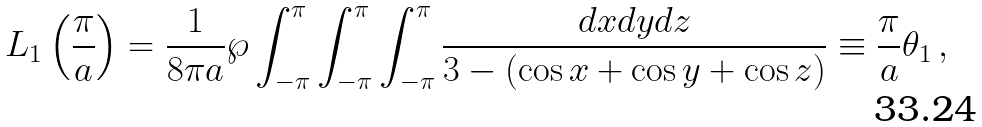<formula> <loc_0><loc_0><loc_500><loc_500>L _ { 1 } \left ( \frac { \pi } { a } \right ) = \frac { 1 } { 8 \pi a } \wp \int ^ { \pi } _ { - \pi } \int ^ { \pi } _ { - \pi } \int ^ { \pi } _ { - \pi } \frac { d x d y d z } { 3 - ( \cos x + \cos y + \cos z ) } \equiv \frac { \pi } { a } \theta _ { 1 } \, ,</formula> 